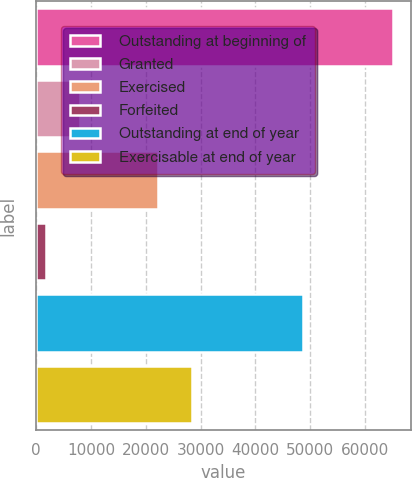<chart> <loc_0><loc_0><loc_500><loc_500><bar_chart><fcel>Outstanding at beginning of<fcel>Granted<fcel>Exercised<fcel>Forfeited<fcel>Outstanding at end of year<fcel>Exercisable at end of year<nl><fcel>65135<fcel>8040.8<fcel>22167<fcel>1697<fcel>48772<fcel>28510.8<nl></chart> 